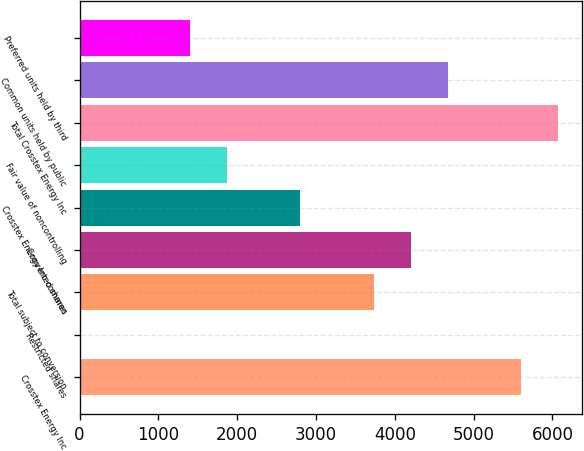<chart> <loc_0><loc_0><loc_500><loc_500><bar_chart><fcel>Crosstex Energy Inc<fcel>Restricted shares<fcel>Total subject to conversion<fcel>Converted shares<fcel>Crosstex Energy Inc common<fcel>Fair value of noncontrolling<fcel>Total Crosstex Energy Inc<fcel>Common units held by public<fcel>Preferred units held by third<nl><fcel>5603.92<fcel>0.4<fcel>3736.08<fcel>4203.04<fcel>2802.16<fcel>1868.24<fcel>6070.88<fcel>4670<fcel>1401.28<nl></chart> 